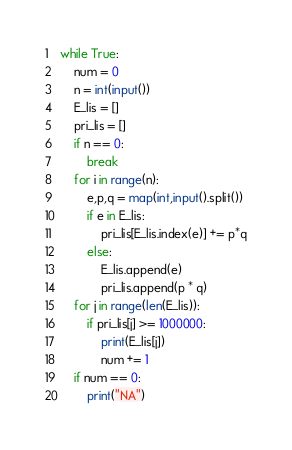Convert code to text. <code><loc_0><loc_0><loc_500><loc_500><_Python_>while True:
    num = 0
    n = int(input())
    E_lis = []
    pri_lis = []
    if n == 0:
        break
    for i in range(n):
        e,p,q = map(int,input().split())
        if e in E_lis:
            pri_lis[E_lis.index(e)] += p*q
        else:
            E_lis.append(e)
            pri_lis.append(p * q)
    for j in range(len(E_lis)):
        if pri_lis[j] >= 1000000:
            print(E_lis[j])
            num += 1
    if num == 0:
        print("NA")</code> 